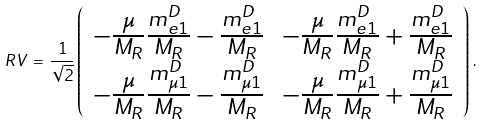<formula> <loc_0><loc_0><loc_500><loc_500>R V \, = \, \frac { 1 } { \sqrt { 2 } } \left ( \begin{array} { c c } - \frac { \mu } { M _ { R } } \frac { m ^ { D } _ { e 1 } } { M _ { R } } - \frac { m ^ { D } _ { e 1 } } { M _ { R } } & - \frac { \mu } { M _ { R } } \frac { m ^ { D } _ { e 1 } } { M _ { R } } + \frac { m ^ { D } _ { e 1 } } { M _ { R } } \\ - \frac { \mu } { M _ { R } } \frac { m ^ { D } _ { \mu 1 } } { M _ { R } } - \frac { m ^ { D } _ { \mu 1 } } { M _ { R } } & - \frac { \mu } { M _ { R } } \frac { m ^ { D } _ { \mu 1 } } { M _ { R } } + \frac { m ^ { D } _ { \mu 1 } } { M _ { R } } \end{array} \right ) \, .</formula> 